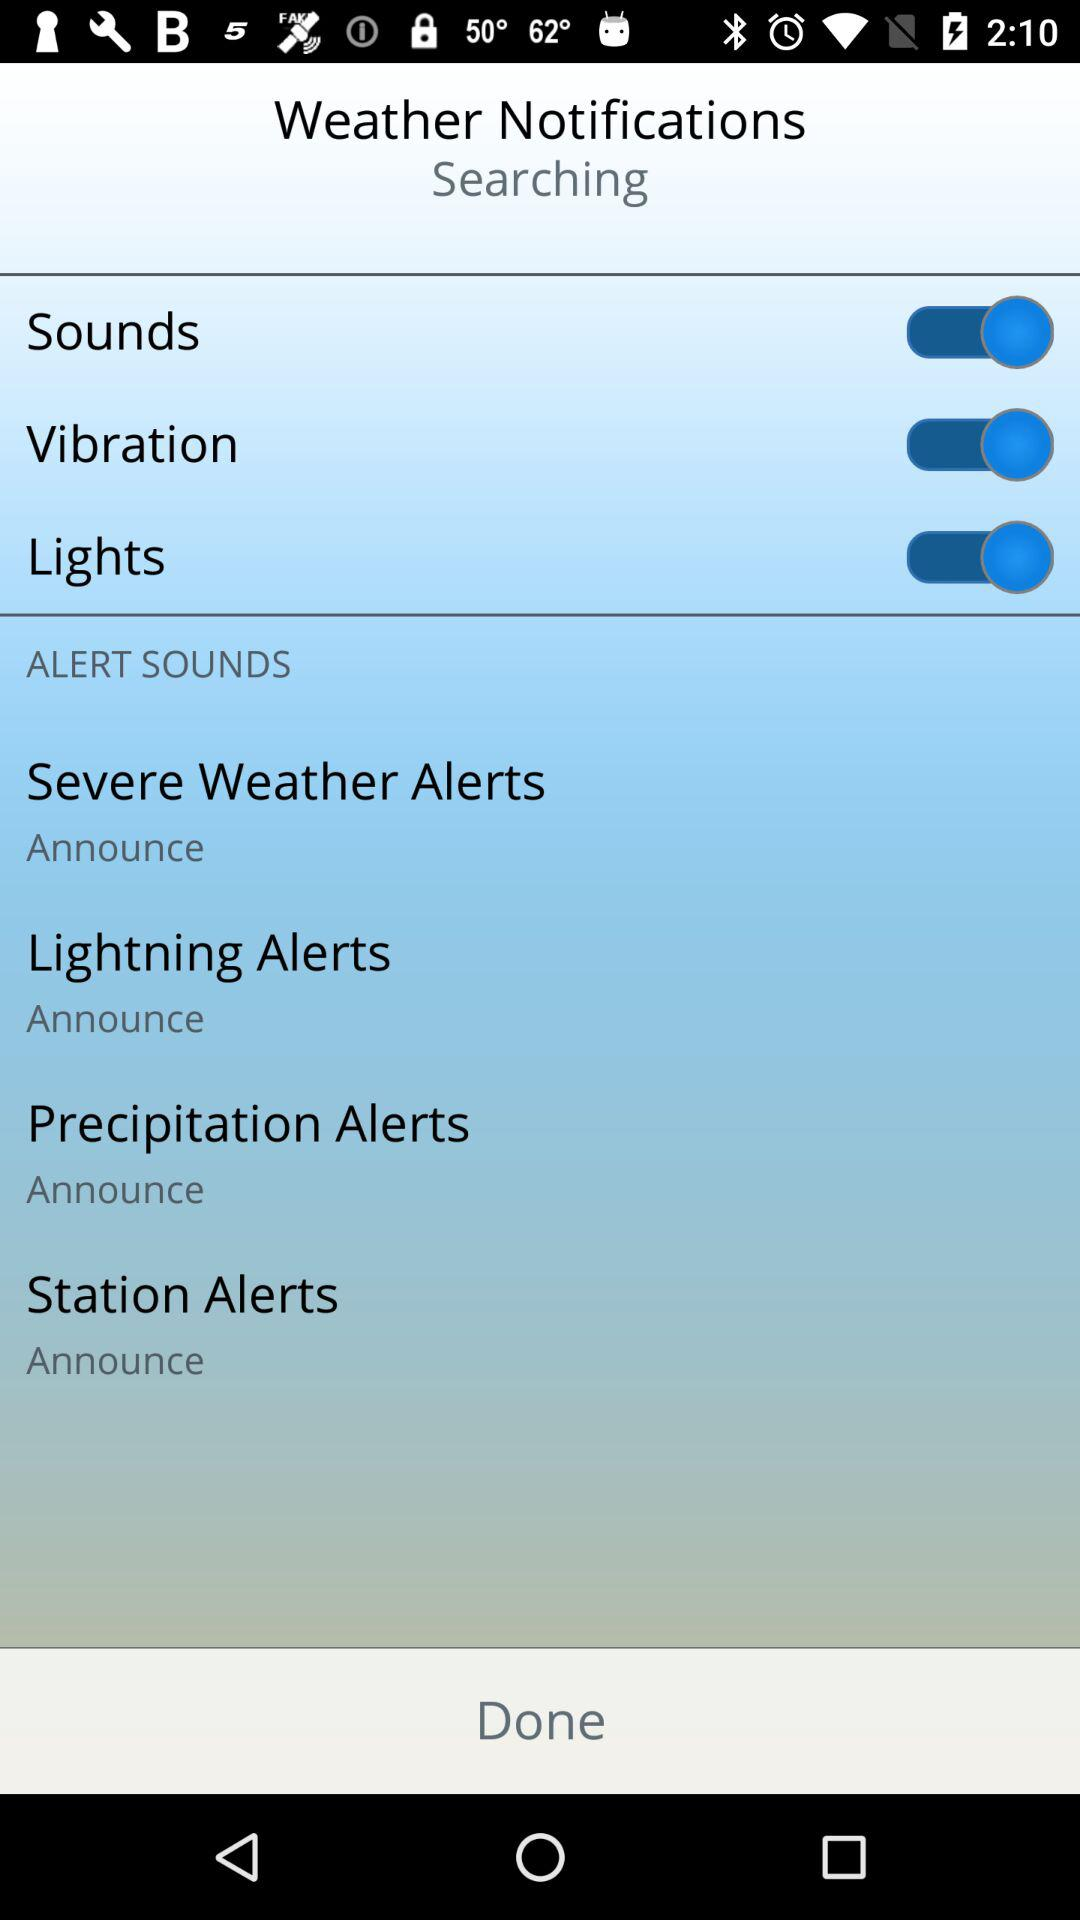What is the current setting for "Lightning Alerts"? The current setting for "Lightning Alerts" is "Announce". 